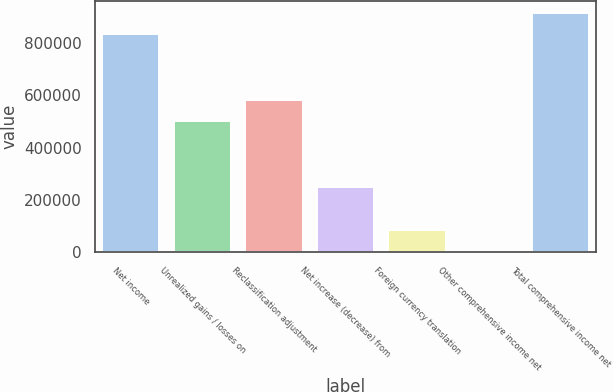Convert chart to OTSL. <chart><loc_0><loc_0><loc_500><loc_500><bar_chart><fcel>Net income<fcel>Unrealized gains / losses on<fcel>Reclassification adjustment<fcel>Net increase (decrease) from<fcel>Foreign currency translation<fcel>Other comprehensive income net<fcel>Total comprehensive income net<nl><fcel>832775<fcel>500427<fcel>583704<fcel>250594<fcel>84039.5<fcel>762<fcel>916052<nl></chart> 